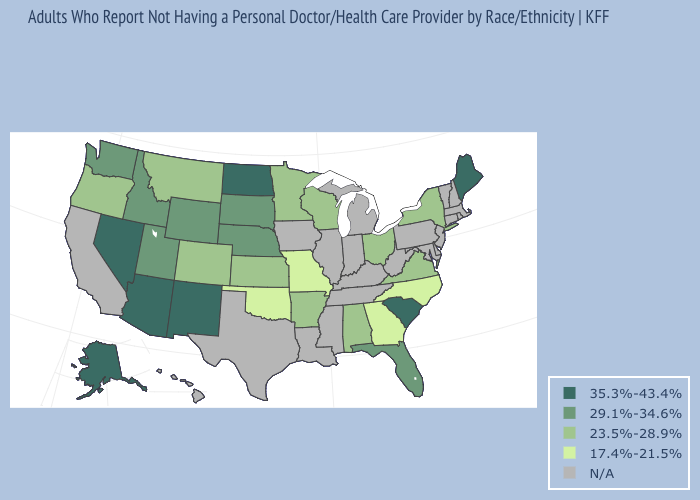Which states have the highest value in the USA?
Concise answer only. Alaska, Arizona, Maine, Nevada, New Mexico, North Dakota, South Carolina. What is the value of New Hampshire?
Answer briefly. N/A. Name the states that have a value in the range 29.1%-34.6%?
Short answer required. Florida, Idaho, Nebraska, South Dakota, Utah, Washington, Wyoming. What is the value of Texas?
Short answer required. N/A. Which states have the lowest value in the USA?
Quick response, please. Georgia, Missouri, North Carolina, Oklahoma. Name the states that have a value in the range 23.5%-28.9%?
Keep it brief. Alabama, Arkansas, Colorado, Kansas, Minnesota, Montana, New York, Ohio, Oregon, Virginia, Wisconsin. Does Virginia have the lowest value in the South?
Be succinct. No. Among the states that border Kentucky , which have the highest value?
Be succinct. Ohio, Virginia. Name the states that have a value in the range 35.3%-43.4%?
Quick response, please. Alaska, Arizona, Maine, Nevada, New Mexico, North Dakota, South Carolina. Among the states that border Massachusetts , which have the highest value?
Keep it brief. New York. Which states hav the highest value in the South?
Keep it brief. South Carolina. Does Arkansas have the lowest value in the South?
Answer briefly. No. What is the value of Massachusetts?
Short answer required. N/A. What is the highest value in the South ?
Keep it brief. 35.3%-43.4%. Does the map have missing data?
Quick response, please. Yes. 